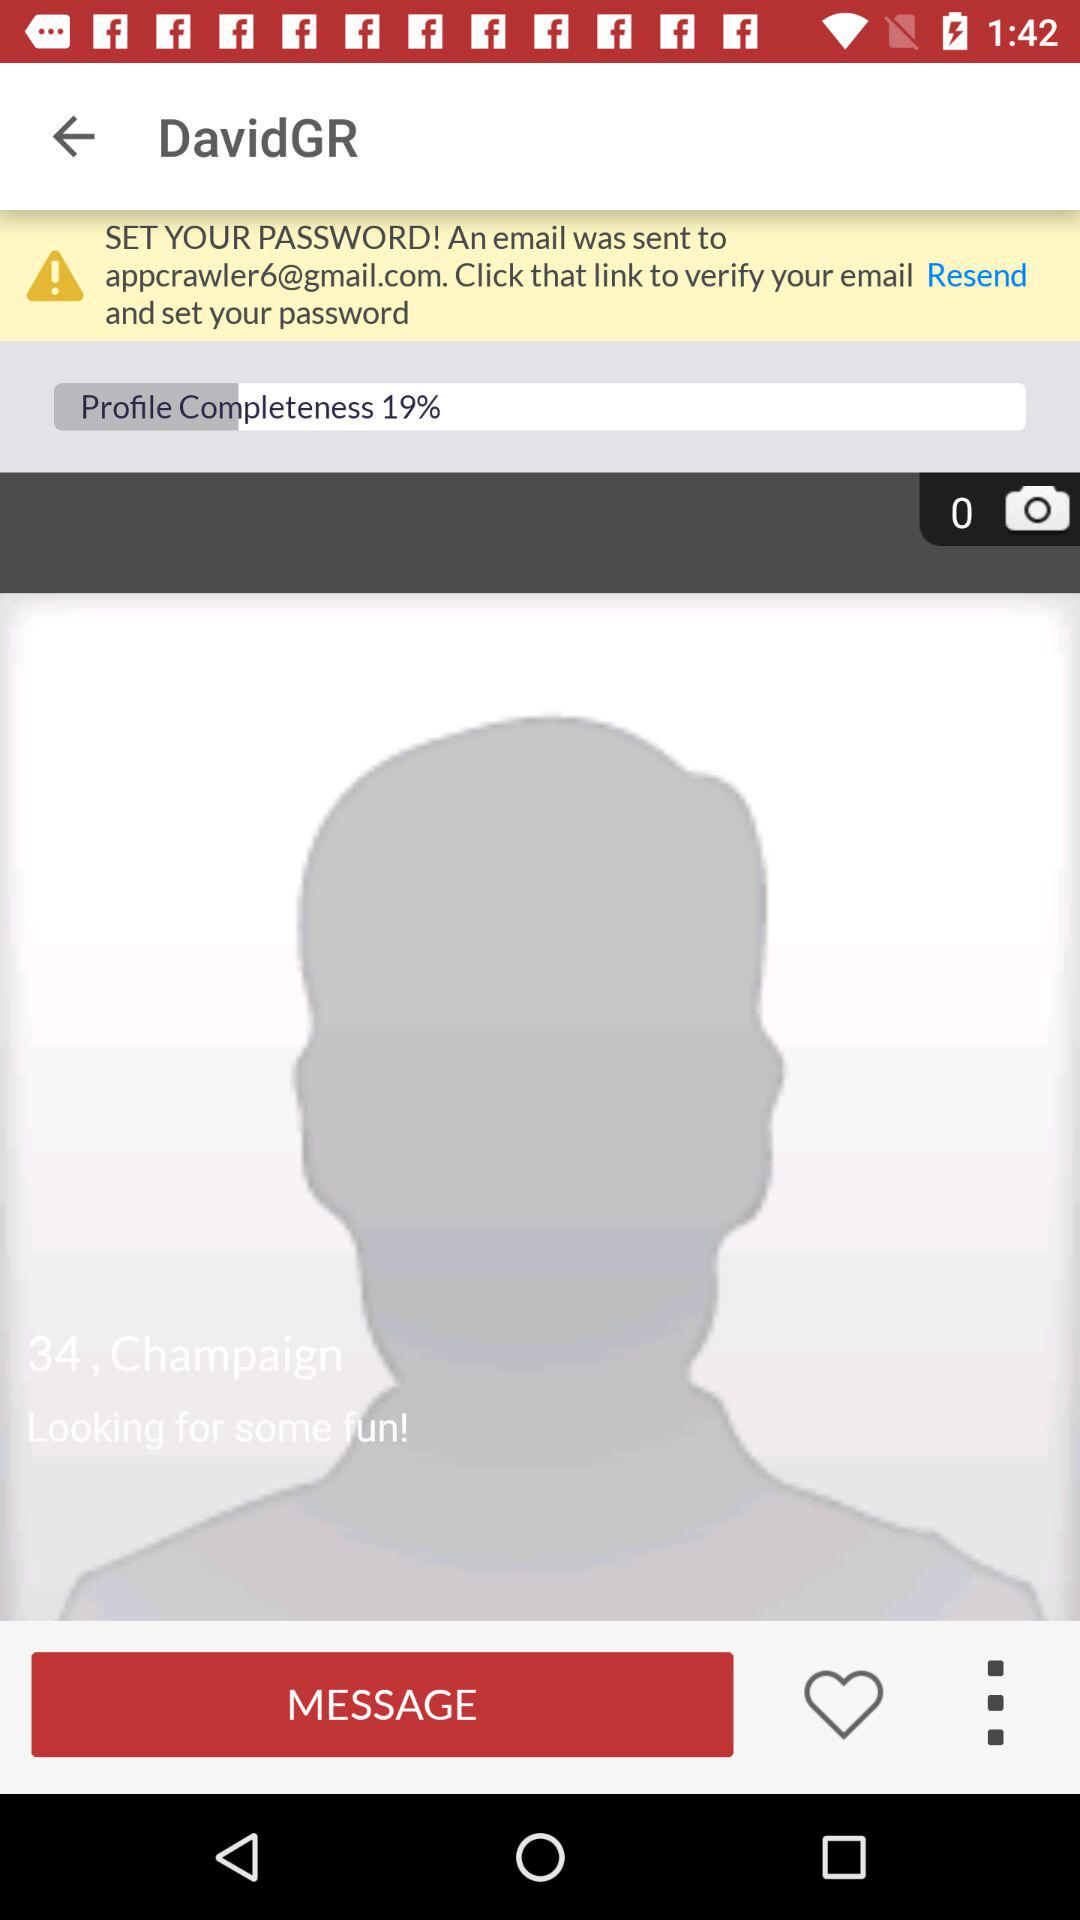To what email address has the email been sent? The email has been sent to appcrawler6@gmail.com. 